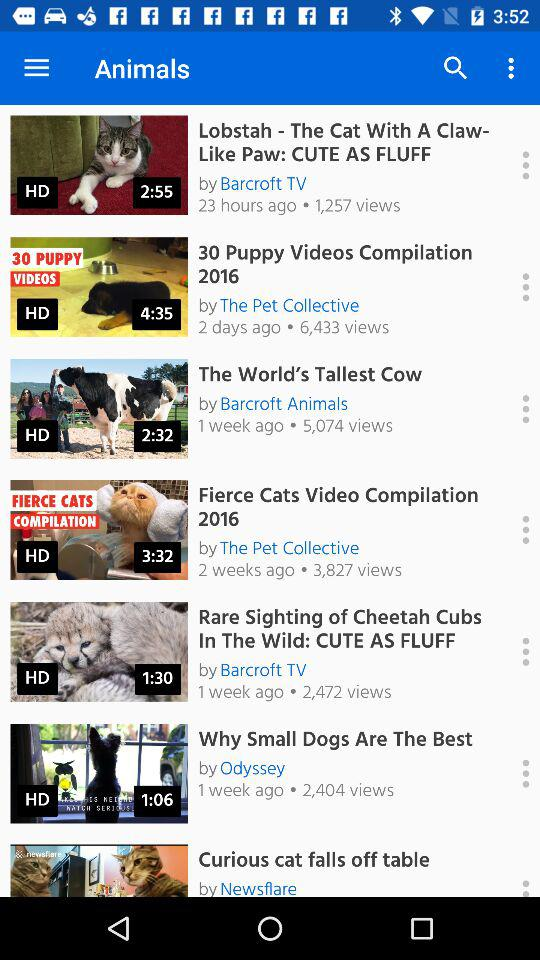What's the duration of the video "Lobstah"? The duration is 2 minutes 55 seconds. 